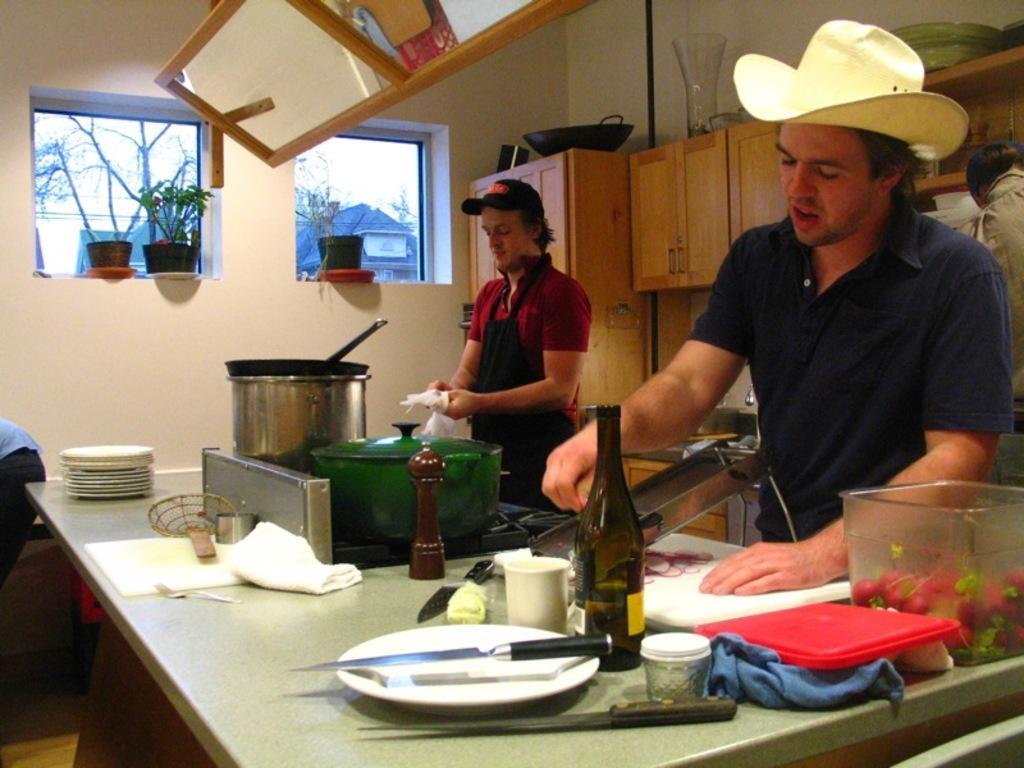Can you describe this image briefly? Two men are preparing a dish in kitchen. 